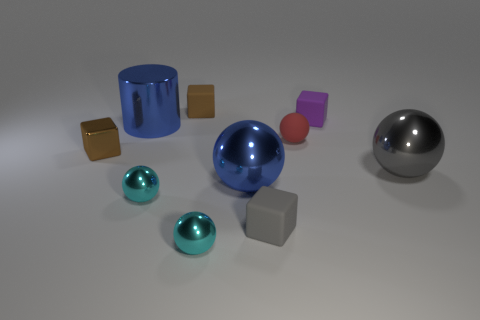Do the large object behind the large gray ball and the large metal ball that is left of the tiny red ball have the same color?
Keep it short and to the point. Yes. Does the brown thing behind the big blue metal cylinder have the same material as the brown thing that is in front of the small purple matte block?
Give a very brief answer. No. Is the number of big spheres less than the number of tiny gray blocks?
Provide a short and direct response. No. There is a small matte object that is left of the gray object left of the red matte sphere; what shape is it?
Provide a succinct answer. Cube. What shape is the purple thing that is the same size as the red rubber object?
Provide a short and direct response. Cube. Is there another brown thing that has the same shape as the brown matte object?
Your answer should be compact. Yes. What material is the gray block?
Ensure brevity in your answer.  Rubber. Are there any big blue metallic balls behind the rubber sphere?
Make the answer very short. No. How many small purple rubber blocks are behind the small rubber block that is in front of the brown shiny object?
Make the answer very short. 1. There is another brown thing that is the same size as the brown matte object; what material is it?
Ensure brevity in your answer.  Metal. 